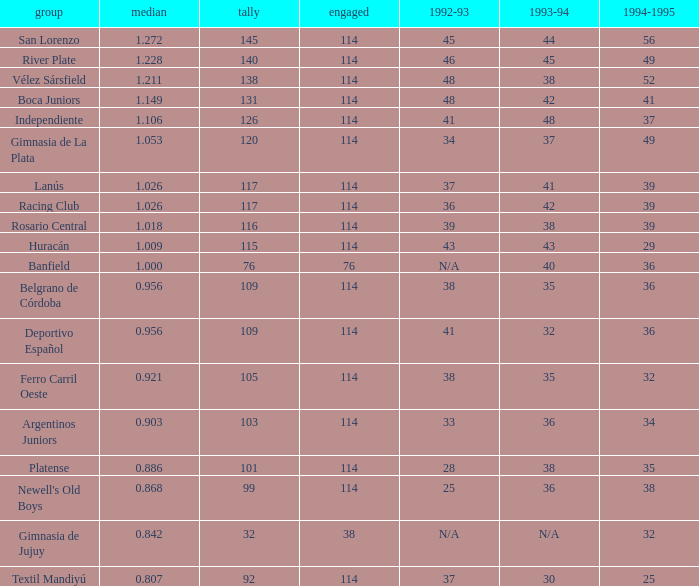Name the most played 114.0. 